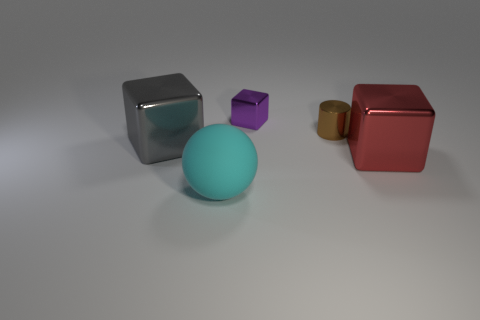There is a large cyan object; is it the same shape as the large shiny object in front of the big gray metal block?
Your answer should be compact. No. What material is the large gray cube?
Ensure brevity in your answer.  Metal. How many shiny things are large blue cylinders or brown cylinders?
Make the answer very short. 1. Is the number of metal blocks that are behind the large gray cube less than the number of small cylinders on the left side of the brown cylinder?
Offer a very short reply. No. There is a cube that is in front of the large cube left of the cyan ball; are there any things that are left of it?
Keep it short and to the point. Yes. Do the small thing that is on the right side of the small block and the big thing right of the cyan ball have the same shape?
Your answer should be compact. No. What is the material of the brown thing that is the same size as the purple shiny cube?
Your answer should be very brief. Metal. Do the large block that is right of the large rubber ball and the object on the left side of the cyan sphere have the same material?
Ensure brevity in your answer.  Yes. There is a shiny object that is the same size as the purple shiny block; what is its shape?
Offer a very short reply. Cylinder. What number of other objects are there of the same color as the small block?
Your answer should be compact. 0. 